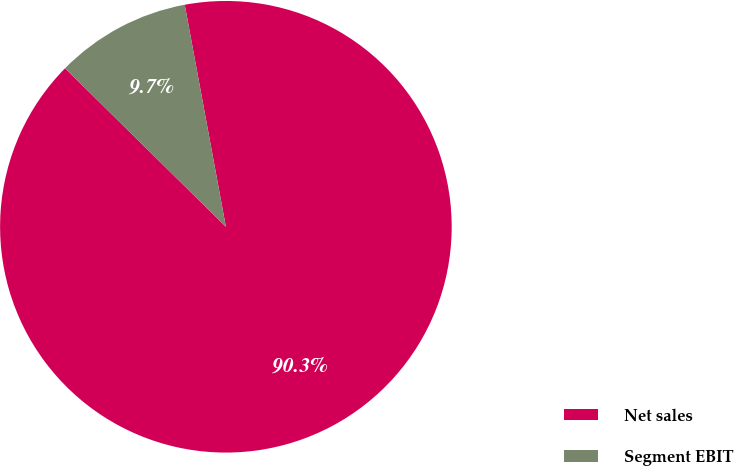Convert chart. <chart><loc_0><loc_0><loc_500><loc_500><pie_chart><fcel>Net sales<fcel>Segment EBIT<nl><fcel>90.3%<fcel>9.7%<nl></chart> 